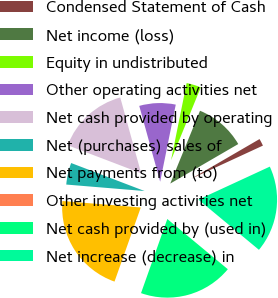Convert chart. <chart><loc_0><loc_0><loc_500><loc_500><pie_chart><fcel>Condensed Statement of Cash<fcel>Net income (loss)<fcel>Equity in undistributed<fcel>Other operating activities net<fcel>Net cash provided by operating<fcel>Net (purchases) sales of<fcel>Net payments from (to)<fcel>Other investing activities net<fcel>Net cash provided by (used in)<fcel>Net increase (decrease) in<nl><fcel>1.49%<fcel>10.45%<fcel>2.99%<fcel>7.46%<fcel>14.92%<fcel>4.48%<fcel>20.89%<fcel>0.0%<fcel>19.4%<fcel>17.91%<nl></chart> 